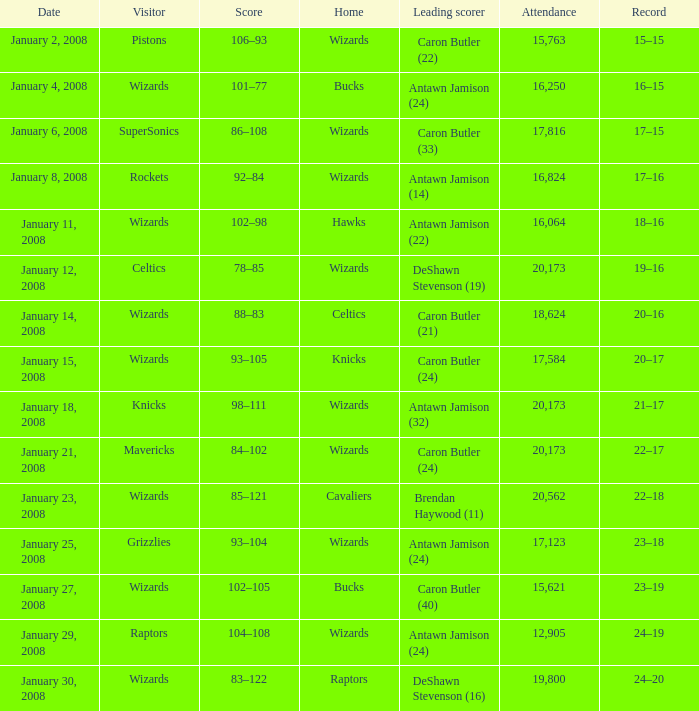How many people were in attendance on January 4, 2008? 16250.0. 